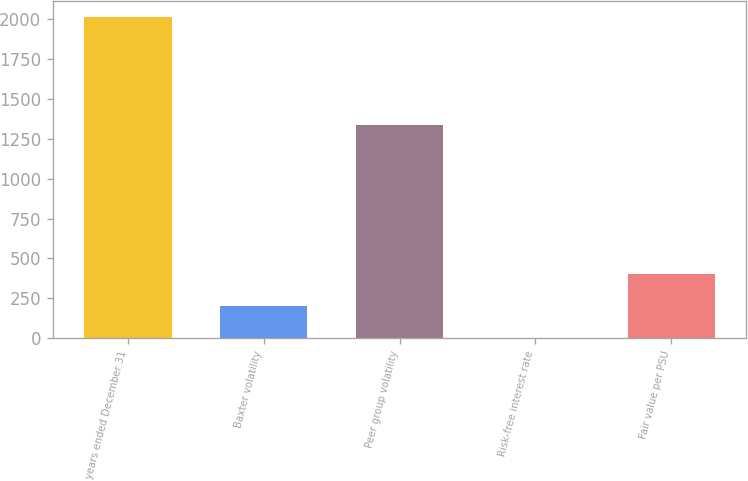Convert chart to OTSL. <chart><loc_0><loc_0><loc_500><loc_500><bar_chart><fcel>years ended December 31<fcel>Baxter volatility<fcel>Peer group volatility<fcel>Risk-free interest rate<fcel>Fair value per PSU<nl><fcel>2013<fcel>201.57<fcel>1338<fcel>0.3<fcel>402.84<nl></chart> 